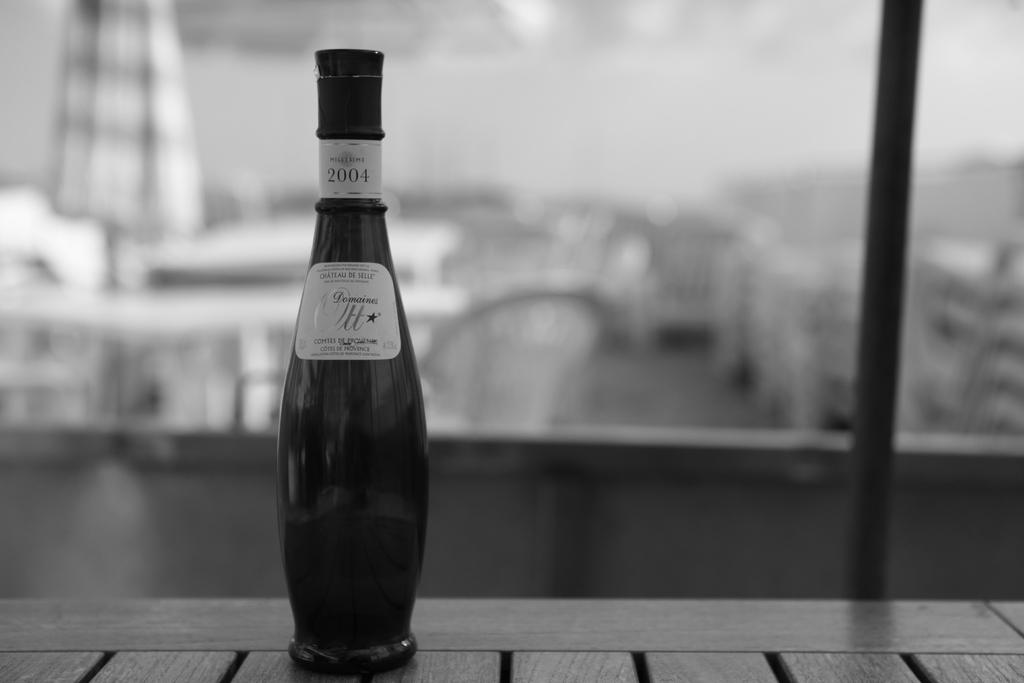<image>
Provide a brief description of the given image. A tapered liquor bottle bears the Domaines Ott label and a year of 2004.. 